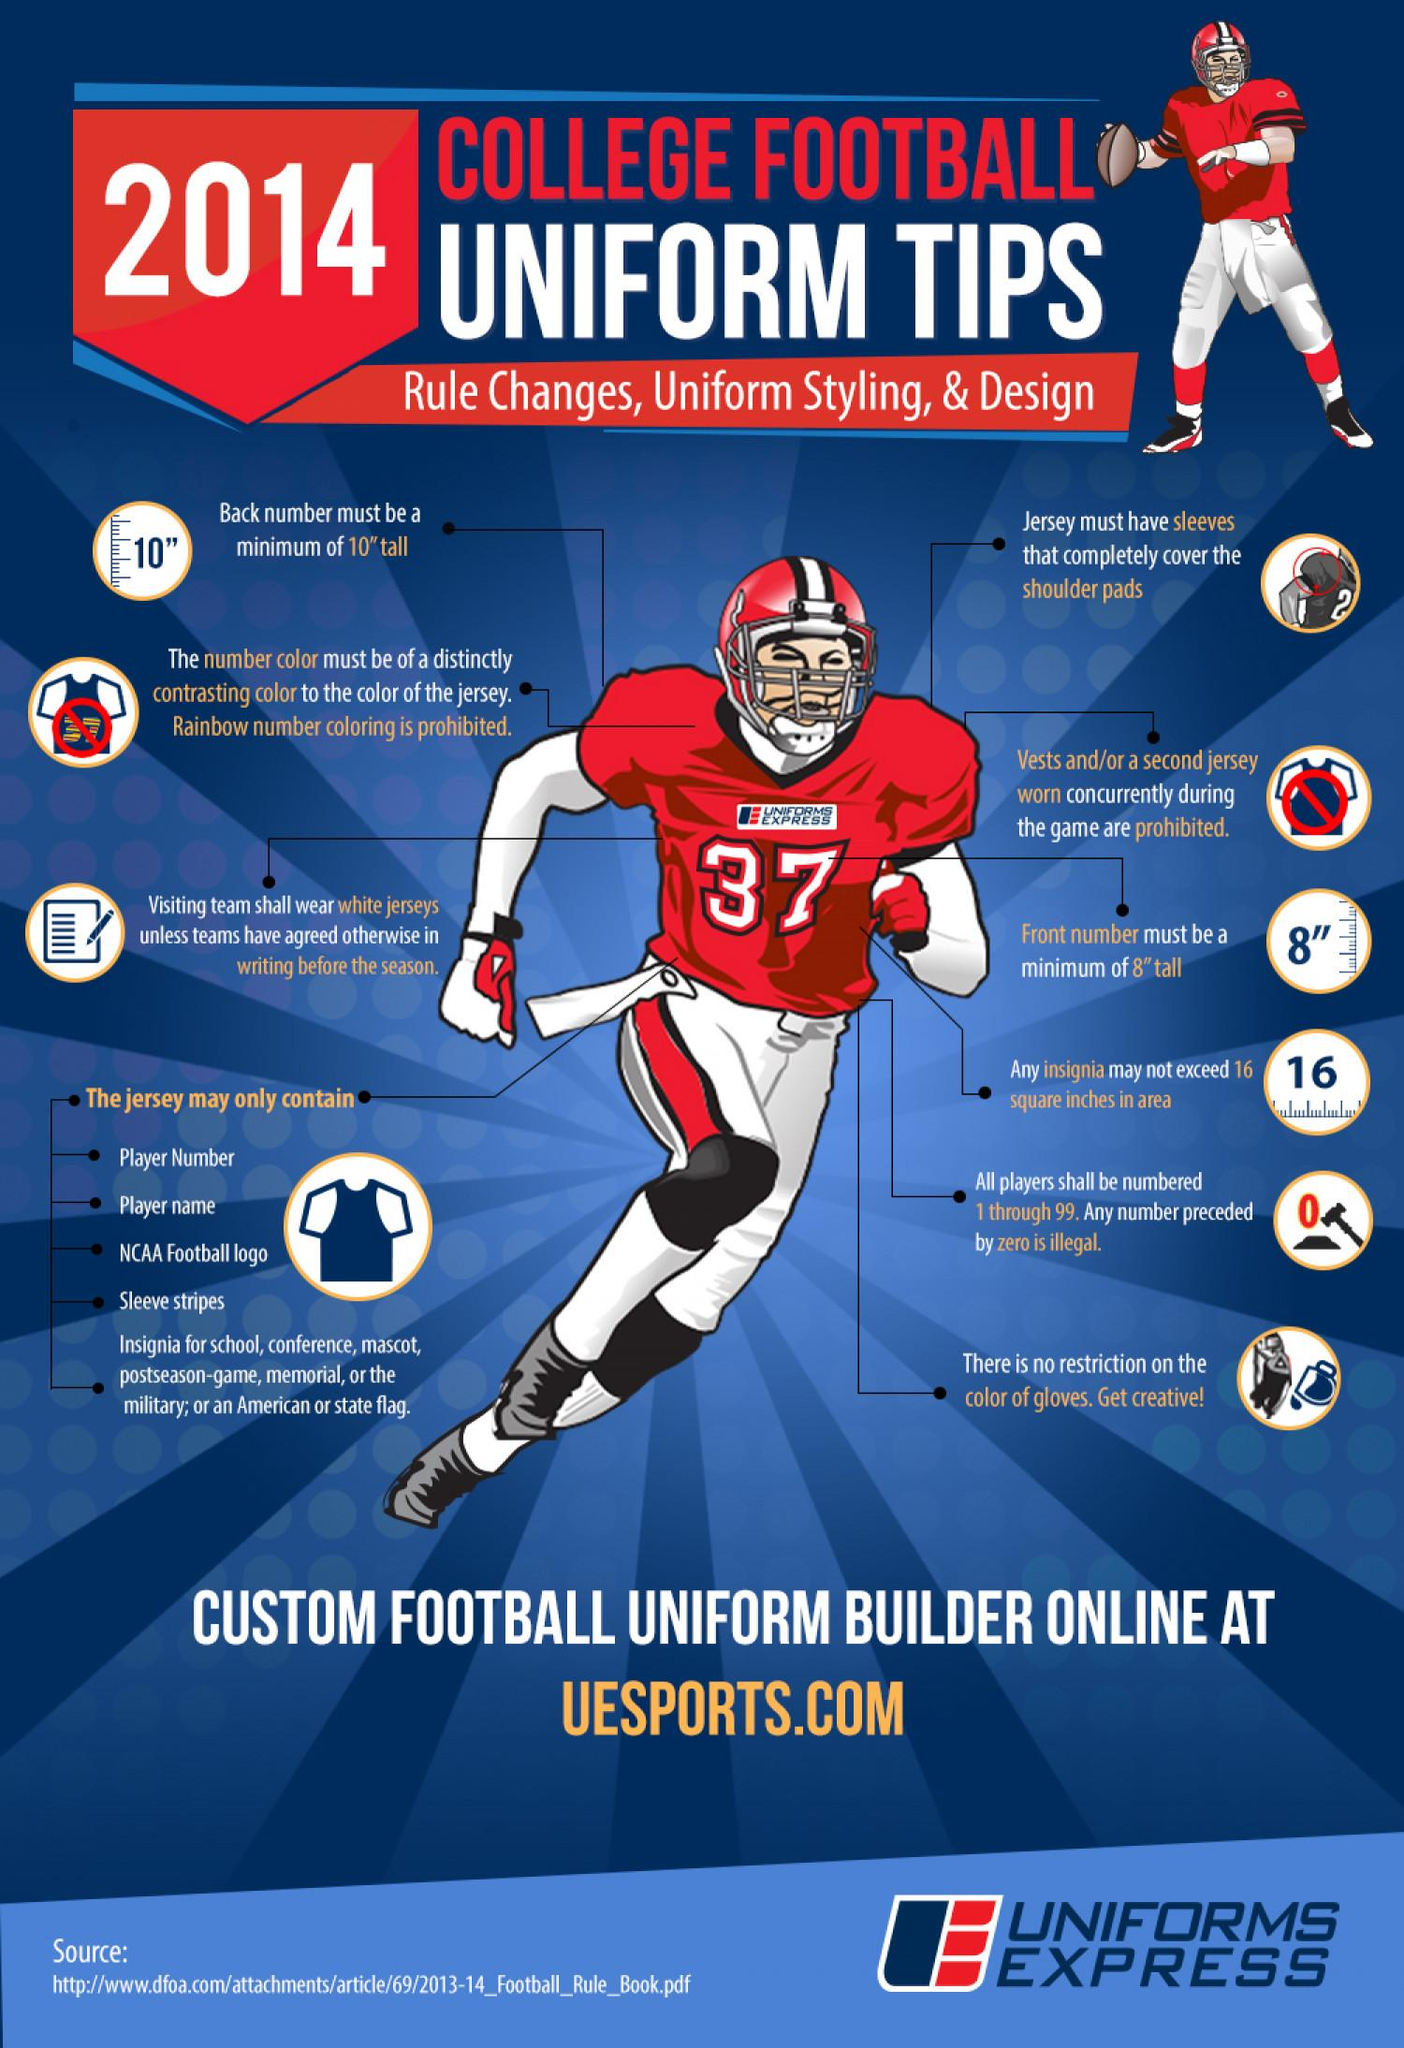Identify some key points in this picture. The rule states that the height of the back number on the jersey should be a minimum of 10 inches tall. It is imperative that five key points be kept in mind while designing a jersey. It is recommended that the height of the back number or front number on a jersey should be a minimum of 8 inches. The color of the jersey shown in the picture is white. 